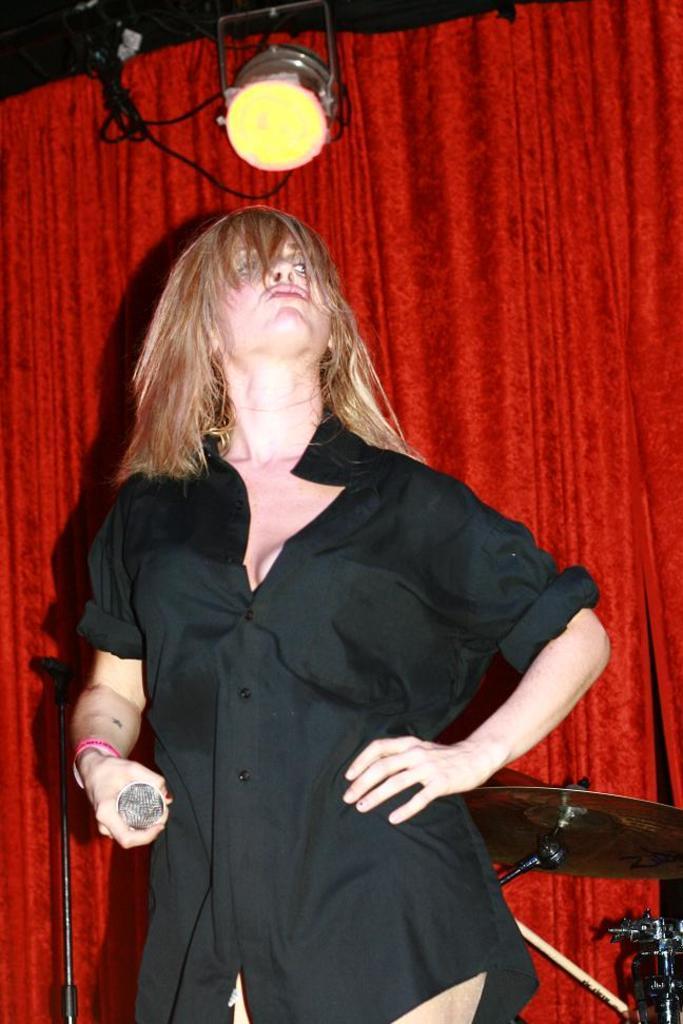Can you describe this image briefly? In the picture we can see a woman standing and holding a microphone and she is in the black shirt and cream color hair and behind her we can see some musical instrument and a curtain which is red in color and on the top of it we can see a light with some wire to it. 